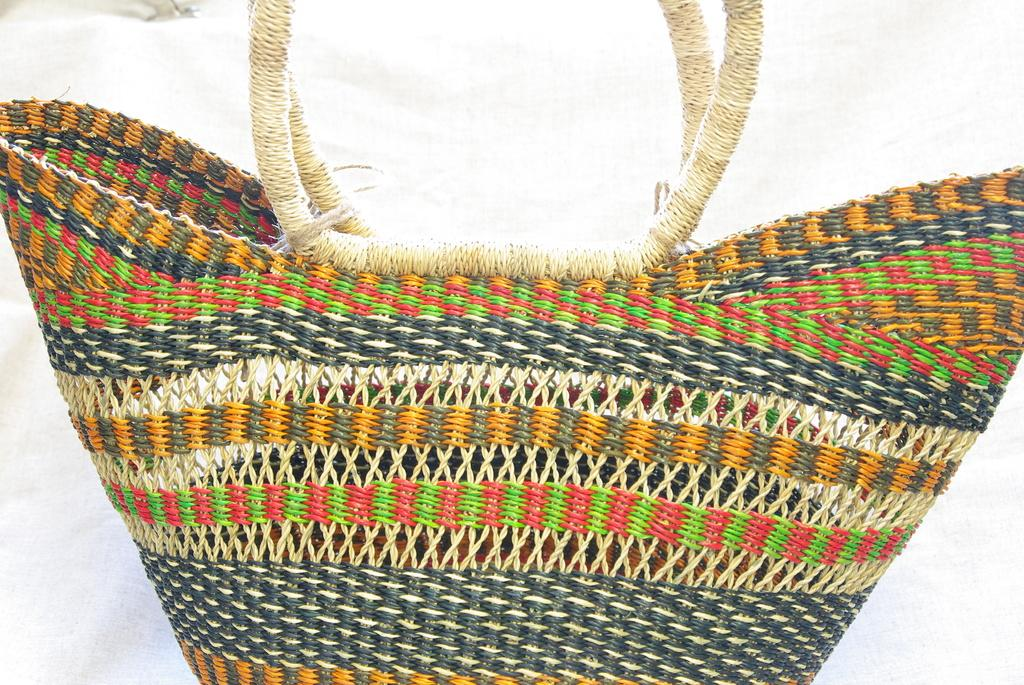What type of item is present in the image? There is a handbag in the image. What material is the handbag made of? The handbag is made of wool. How many sofas are visible in the image? There are no sofas present in the image; it only features a handbag made of wool. What type of washing method is used for the handbag in the image? The image does not show any washing method or activity related to the handbag. 